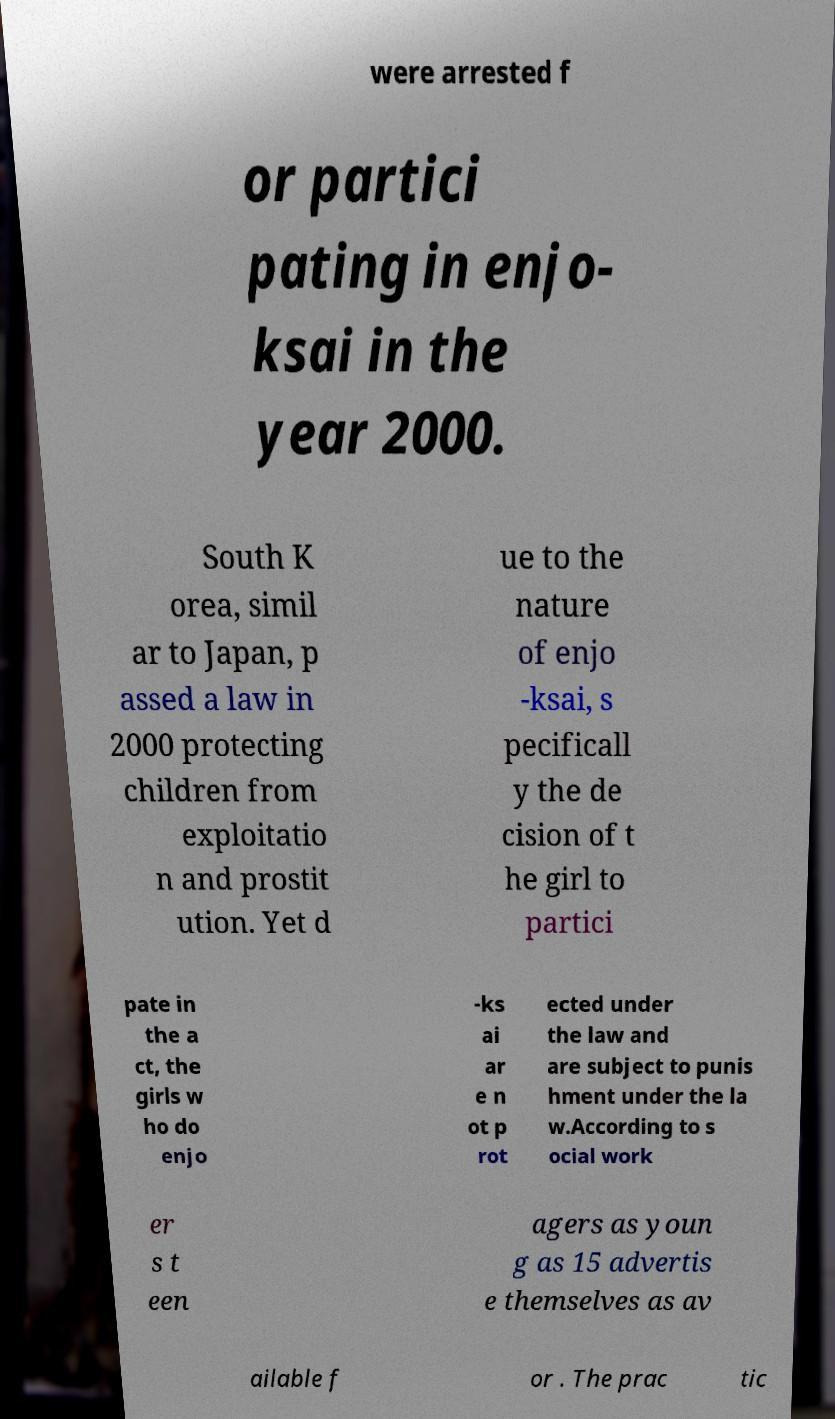Can you accurately transcribe the text from the provided image for me? were arrested f or partici pating in enjo- ksai in the year 2000. South K orea, simil ar to Japan, p assed a law in 2000 protecting children from exploitatio n and prostit ution. Yet d ue to the nature of enjo -ksai, s pecificall y the de cision of t he girl to partici pate in the a ct, the girls w ho do enjo -ks ai ar e n ot p rot ected under the law and are subject to punis hment under the la w.According to s ocial work er s t een agers as youn g as 15 advertis e themselves as av ailable f or . The prac tic 